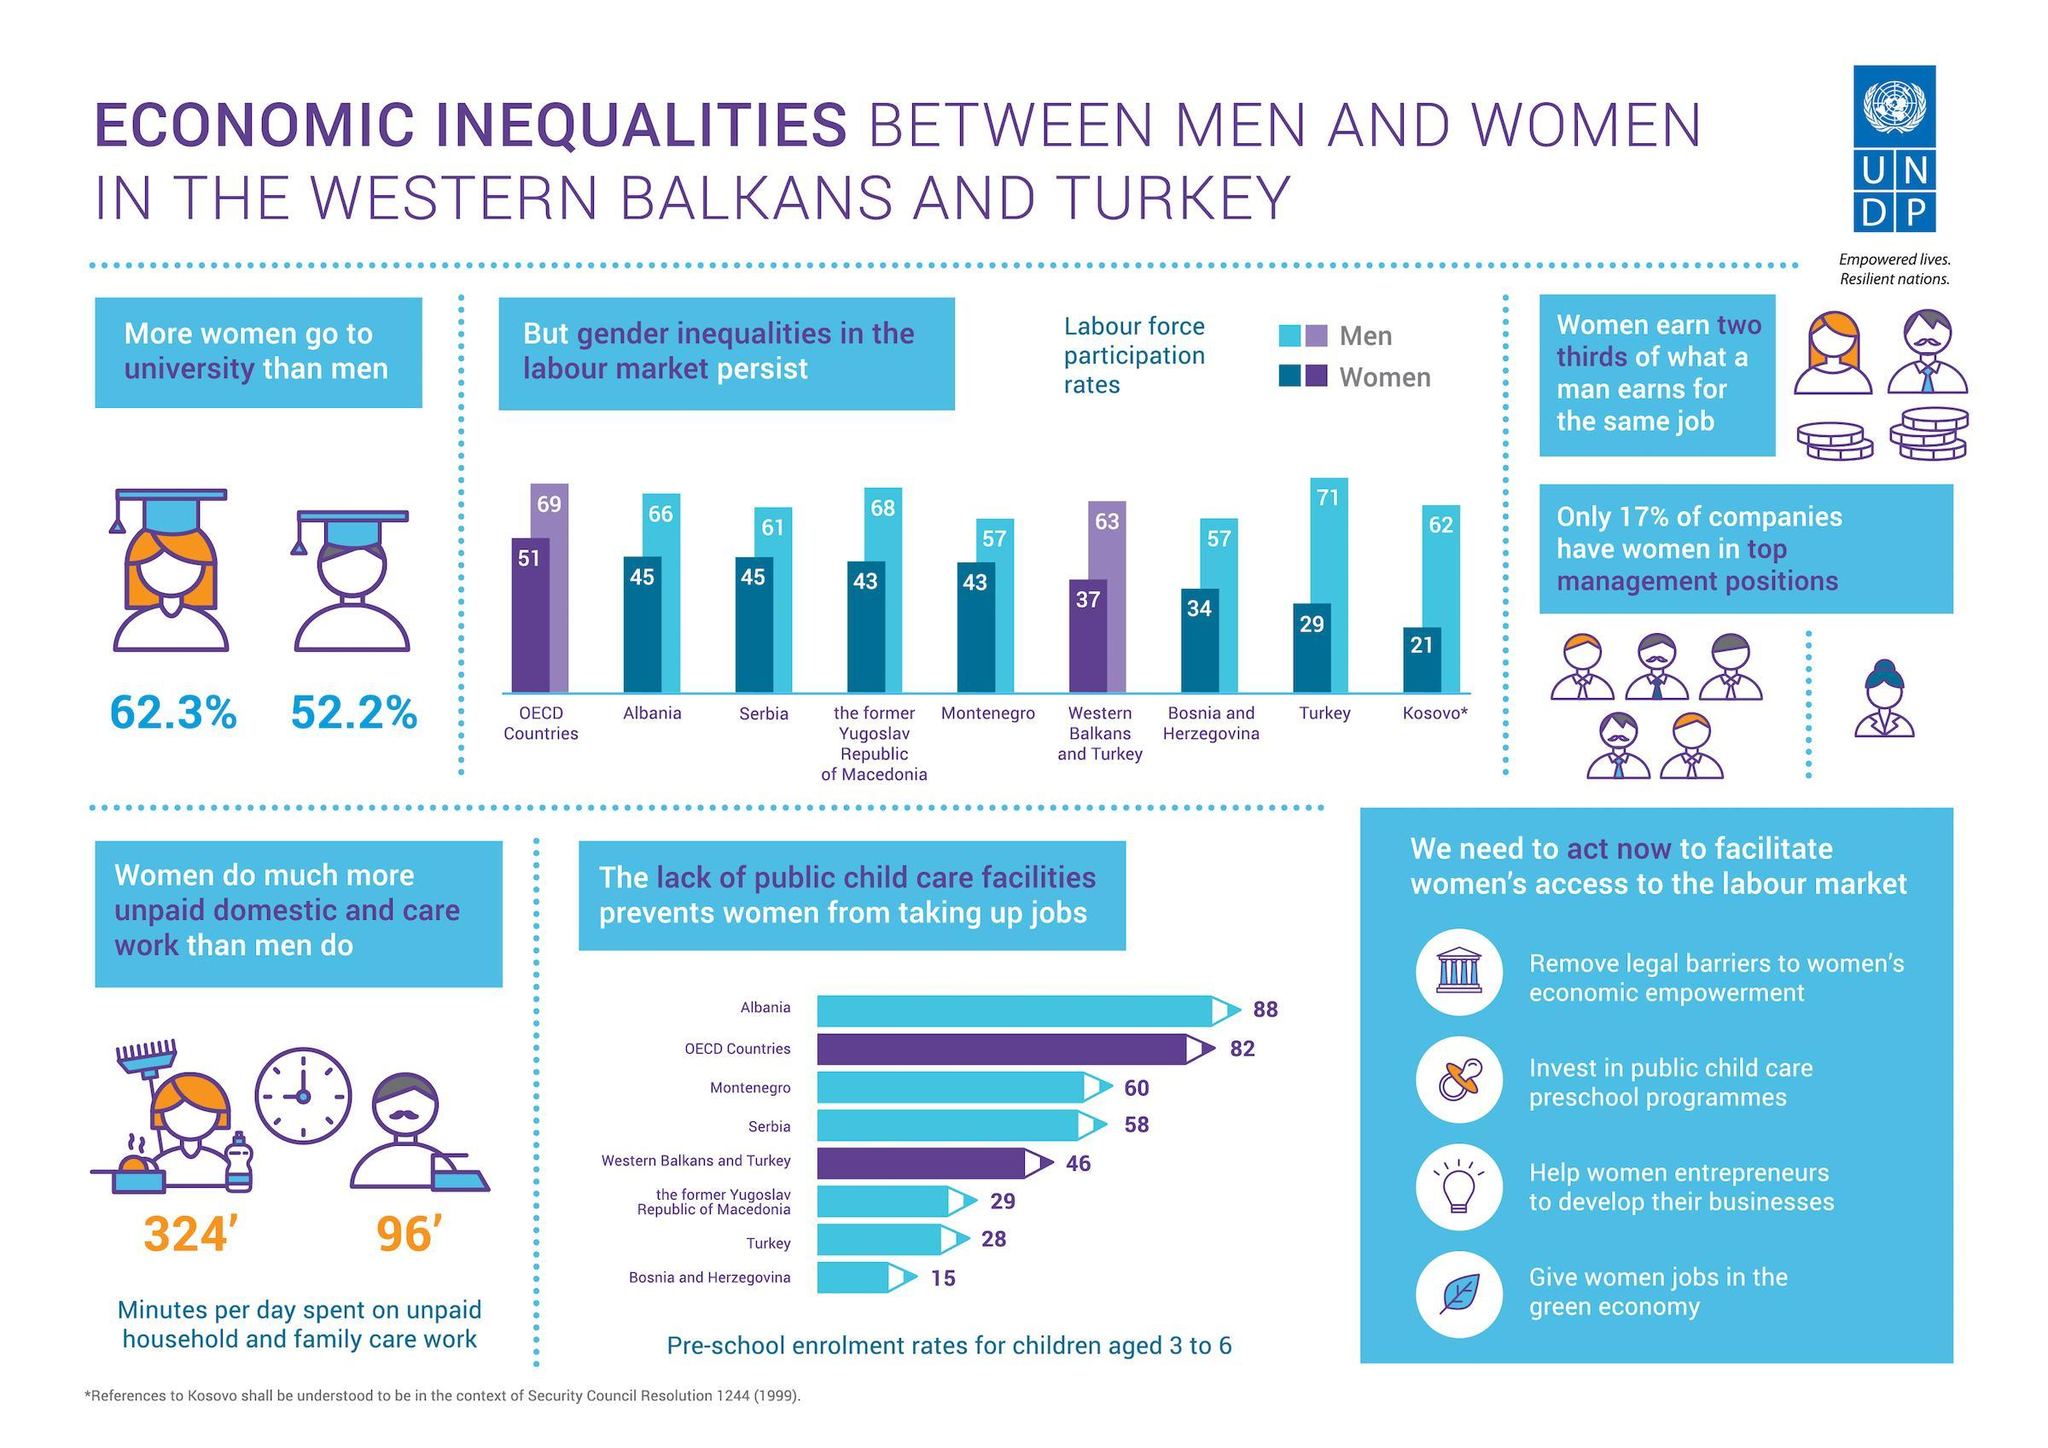What is the pre-school enrollment rates for children aged 3 to 6 in Serbia and Montenegro, taken together?
Answer the question with a short phrase. 118 What percentage of companies don't have women in top managed positions? 83% What percentage of women don't go to university? 37.7% What is the pre-school enrollment rates for children aged 3 to 6 in Turkey and Albania, taken together? 116 What percentage of men don't go to university? 47.8% 